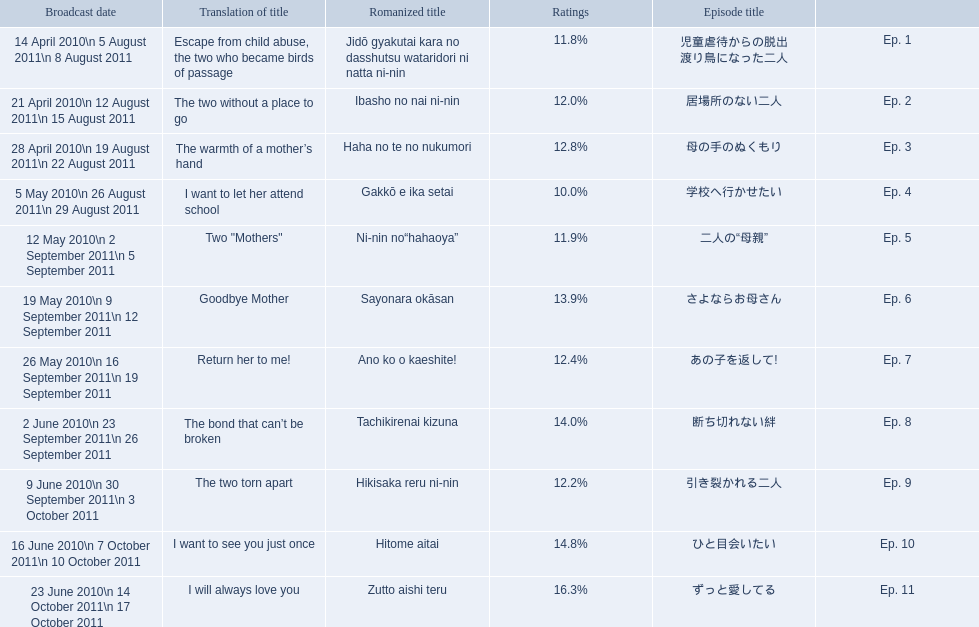What are all the episodes? Ep. 1, Ep. 2, Ep. 3, Ep. 4, Ep. 5, Ep. 6, Ep. 7, Ep. 8, Ep. 9, Ep. 10, Ep. 11. Of these, which ones have a rating of 14%? Ep. 8, Ep. 10. Of these, which one is not ep. 10? Ep. 8. 